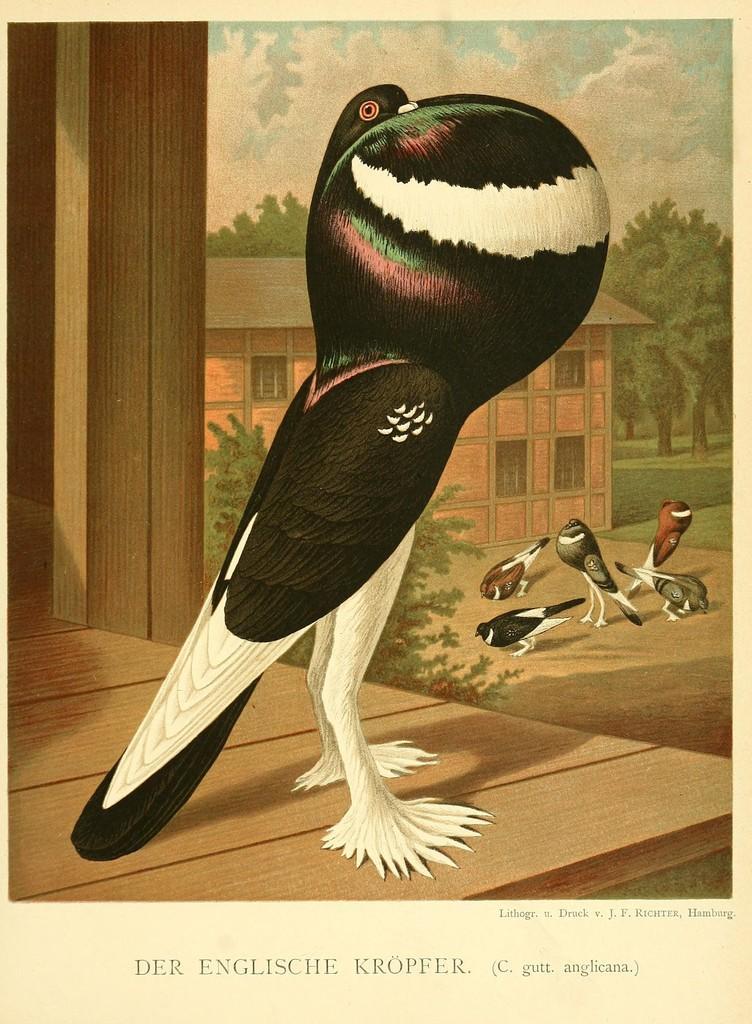How would you summarize this image in a sentence or two? In the picture I can see the poster. On the poster I can see the birds, a house and trees. There are clouds in the sky. 